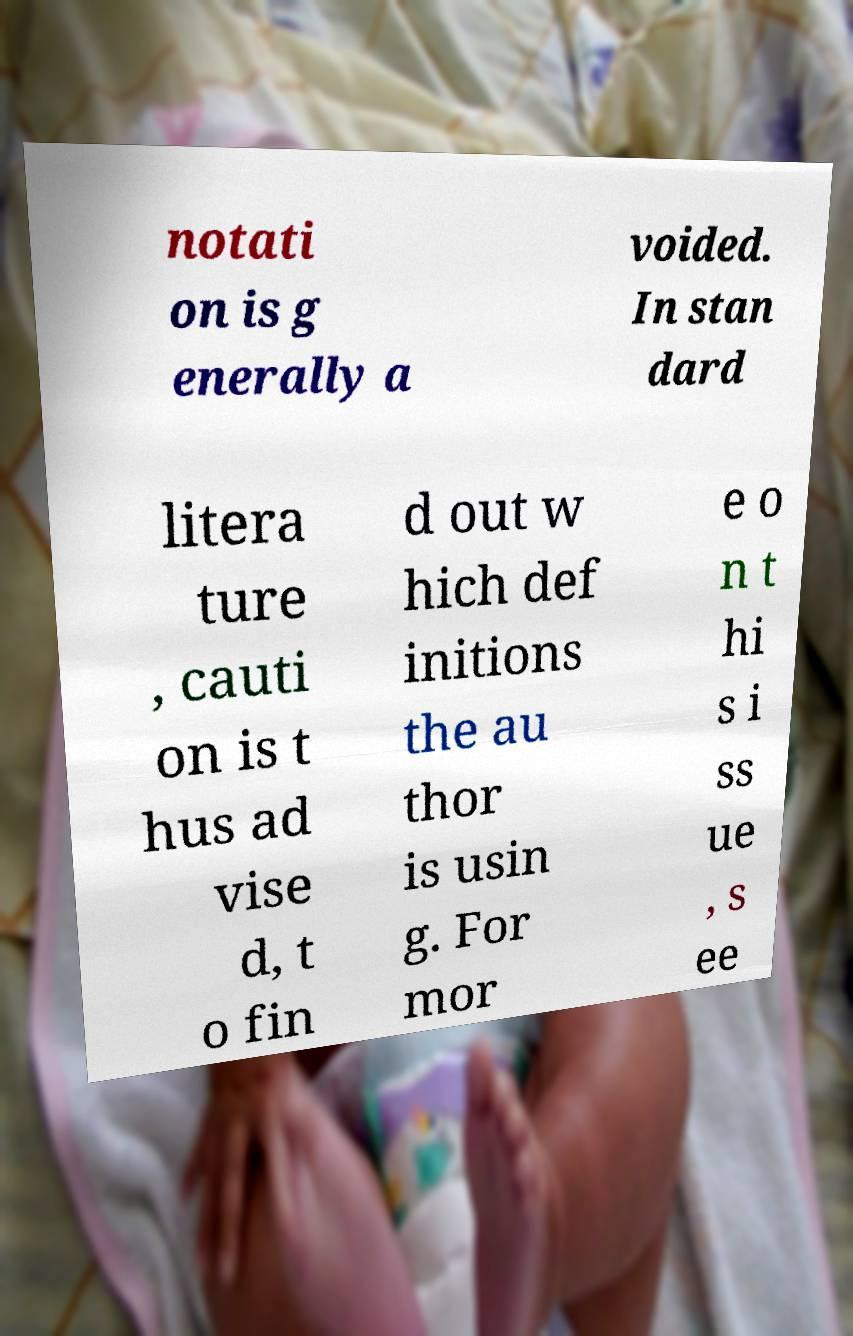Can you accurately transcribe the text from the provided image for me? notati on is g enerally a voided. In stan dard litera ture , cauti on is t hus ad vise d, t o fin d out w hich def initions the au thor is usin g. For mor e o n t hi s i ss ue , s ee 